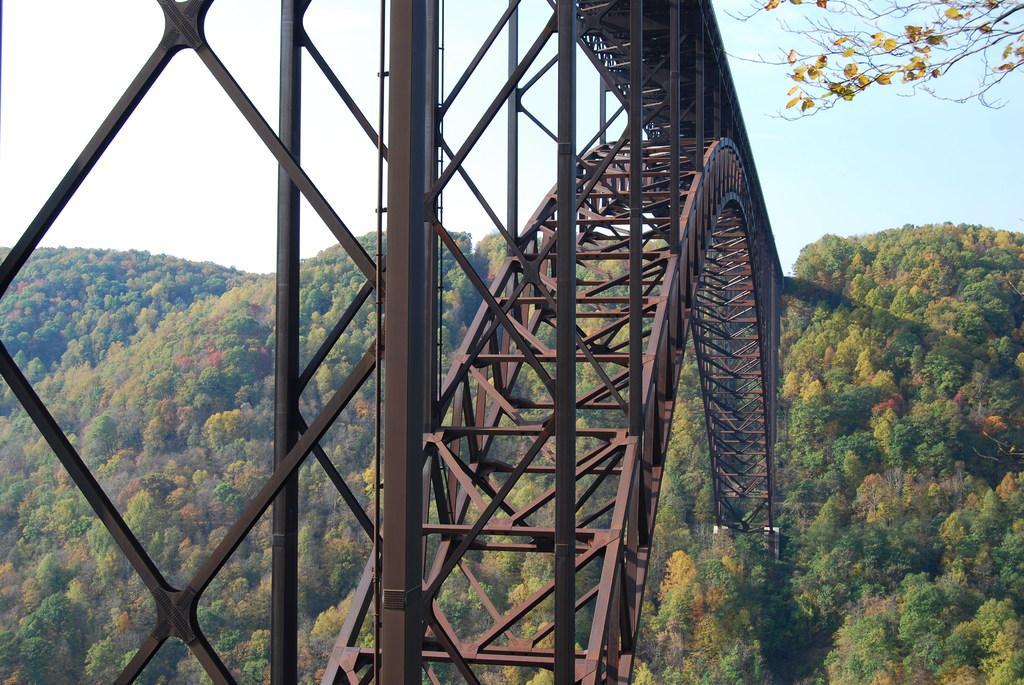Can you describe this image briefly? In this image I see the iron rods over here and I see number of trees and I see leaves on the stems and I see the clear sky. 